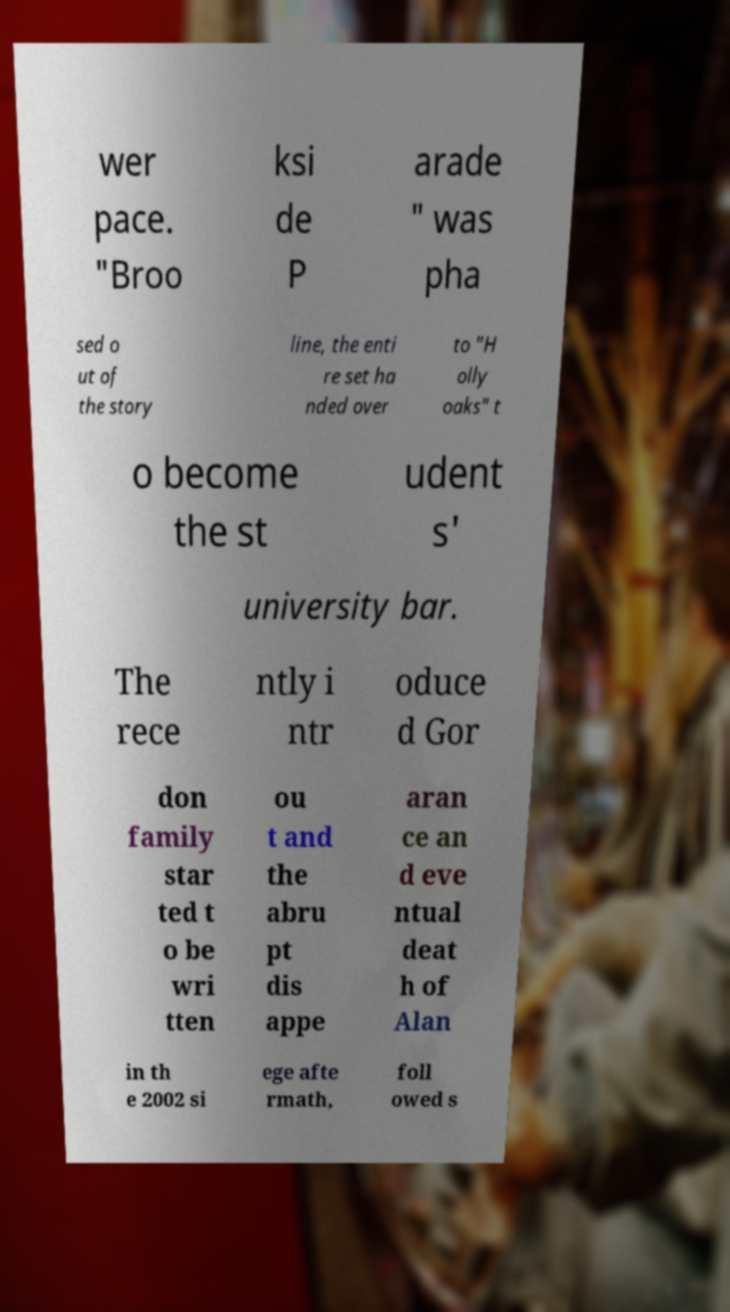Can you read and provide the text displayed in the image?This photo seems to have some interesting text. Can you extract and type it out for me? wer pace. "Broo ksi de P arade " was pha sed o ut of the story line, the enti re set ha nded over to "H olly oaks" t o become the st udent s' university bar. The rece ntly i ntr oduce d Gor don family star ted t o be wri tten ou t and the abru pt dis appe aran ce an d eve ntual deat h of Alan in th e 2002 si ege afte rmath, foll owed s 